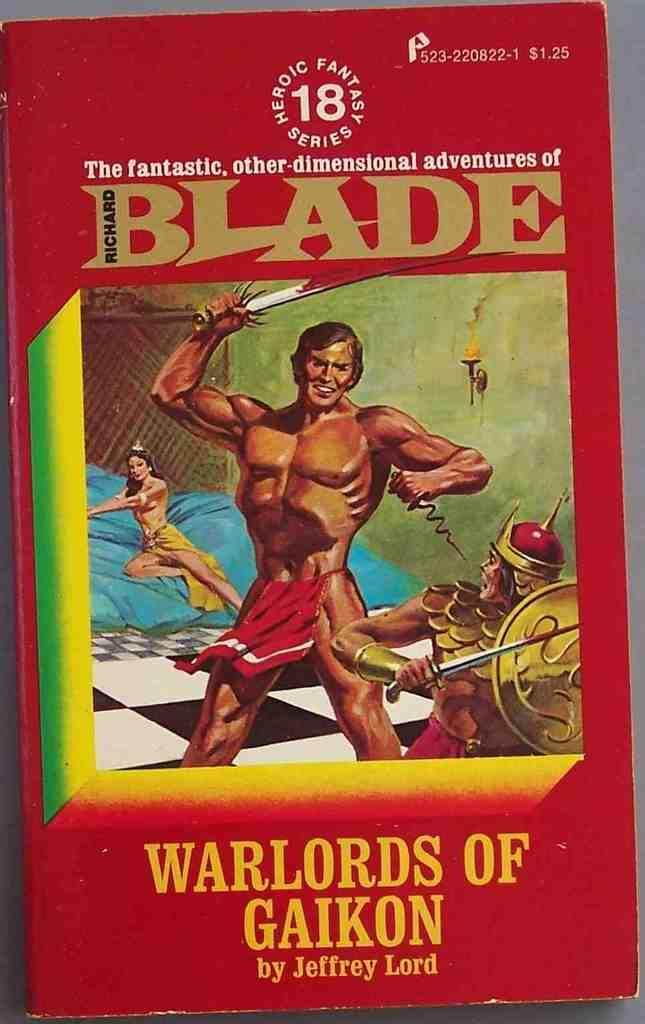What is present on the table in the image? There is a book on the table in the image. What is the color of the book? The book is red in color. What type of canvas is being used for the test in the image? There is no canvas or test present in the image; it only features a table with a red book on it. 